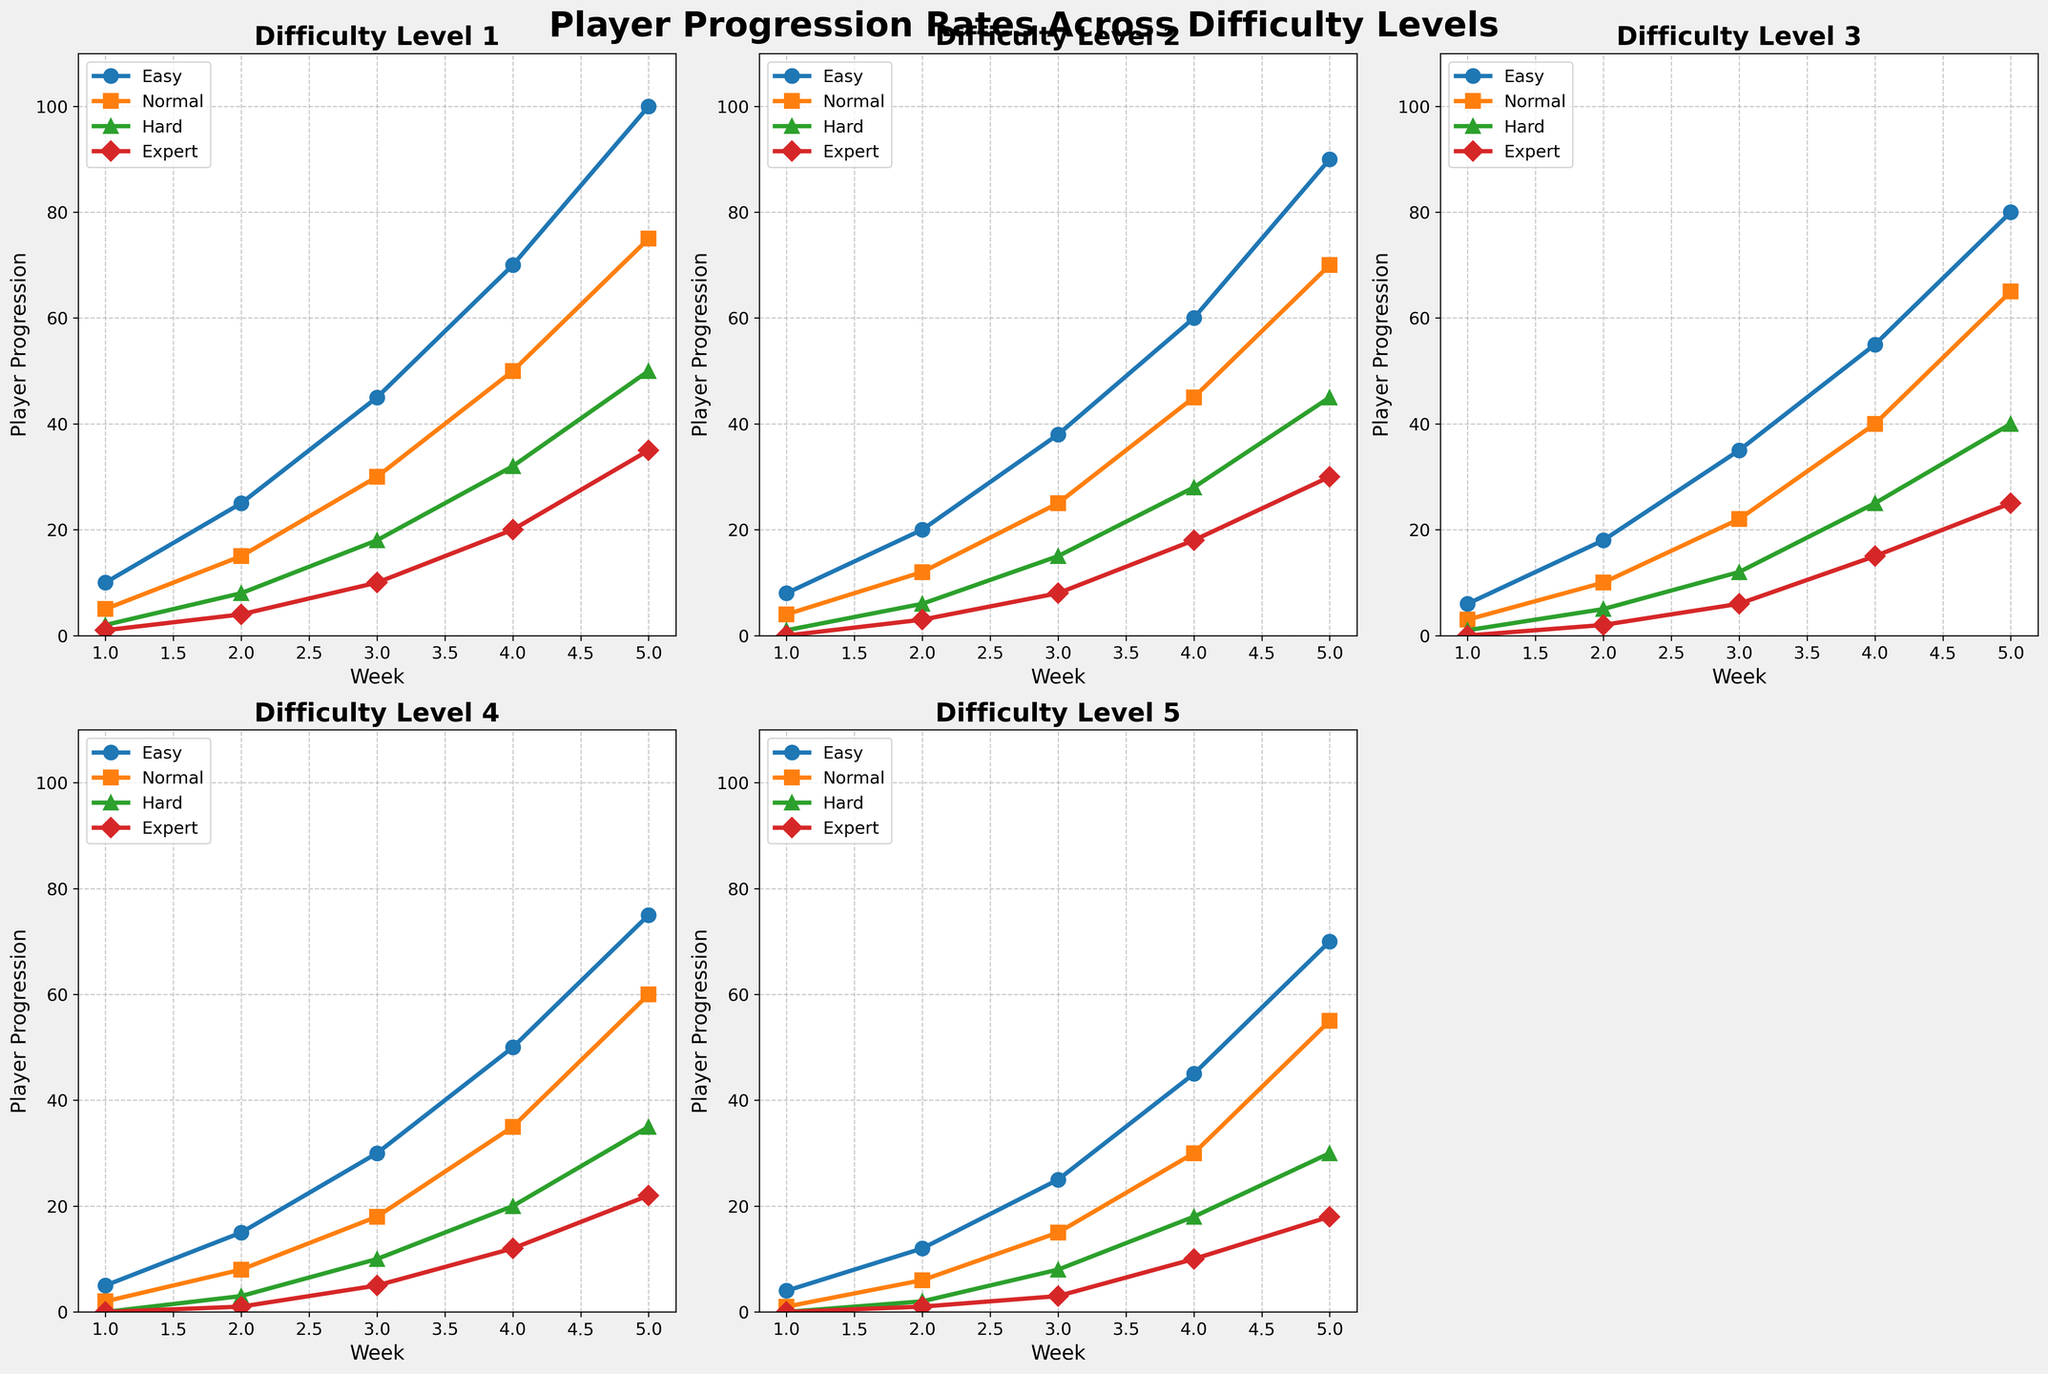Which difficulty level has the highest player progression by Week 5? By visually comparing the end points (Week 5) of all difficulty levels in the subplots, the 'Easy' level has the highest value in each subplot, specifically reaching 100, 90, 80, 75, and 70 respectively.
Answer: Easy How does player progression on 'Hard' difficulty compare between Week 1 and Week 5? For each difficulty level subplot, look at the 'Hard' line and compare its starting value at Week 1 and its ending value at Week 5. The values are (2, 50), (1, 45), (1, 40), (0, 35), and (0, 30), respectively. In all cases, the progression significantly increases from Week 1 to Week 5.
Answer: Increases Which difficulty level shows the least progression for the 'Expert' level by Week 3? Look at the third plot points (Week 3) across all difficulty levels for the 'Expert' line. The values are 10, 8, 6, 5, and 3. The smallest value here is 3, corresponding to Difficulty level 5.
Answer: Difficulty 5 What is the average progression rate for the 'Normal' level in Difficulty 3? To find the average, sum the 'Normal' values for Difficulty 3 (3, 10, 22, 40, 65) and divide by 5. The sum is 140, so the average progression rate is 140/5 = 28.
Answer: 28 Which difficulty level had a greater increase in player progression from Week 2 to Week 4 for the 'Easy' level, Difficulty 1 or Difficulty 2? For Difficulty 1, the 'Easy' values are 25 (Week 2) and 70 (Week 4), resulting in an increase of 45. For Difficulty 2, the 'Easy' values are 20 (Week 2) and 60 (Week 4), resulting in an increase of 40.
Answer: Difficulty 1 How does the player progression for 'Expert' in Week 3 compare between Difficulty 2 and Difficulty 4? The 'Expert' value for Week 3 in Difficulty 2 is 8, while for Difficulty 4 it is 5. Thus, the value for Difficulty 2 is higher.
Answer: Difficulty 2 is higher By Week 4, which difficulty level shows the highest total player progression for all levels combined? Sum the progression values for all levels ('Easy', 'Normal', 'Hard', 'Expert') in Week 4 for each difficulty. Resulting sums are:
- Difficulty 1: 70+50+32+20 = 172
- Difficulty 2: 60+45+28+18 = 151
- Difficulty 3: 55+40+25+15 = 135
- Difficulty 4: 50+35+20+12 = 117
- Difficulty 5: 45+30+18+10 = 103
Therefore, Difficulty 1 has the highest total progression.
Answer: Difficulty 1 Does the progression rate for 'Normal' in Difficulty 1 show a consistent trend? Observing the 'Normal' line in Difficulty 1, the values are 5, 15, 30, 50, and 75 for Weeks 1 to 5. The progression rate shows a consistent increasing trend.
Answer: Yes, it shows a consistent increasing trend Which difficulty level’s player progression for 'Hard' remains at 0 at Week 1? Look at the 'Hard' values at Week 1 across all subplots. Here, Difficulty 4 and Difficulty 5 have their 'Hard' progression values remaining at 0 at Week 1.
Answer: Difficulty 4 and 5 